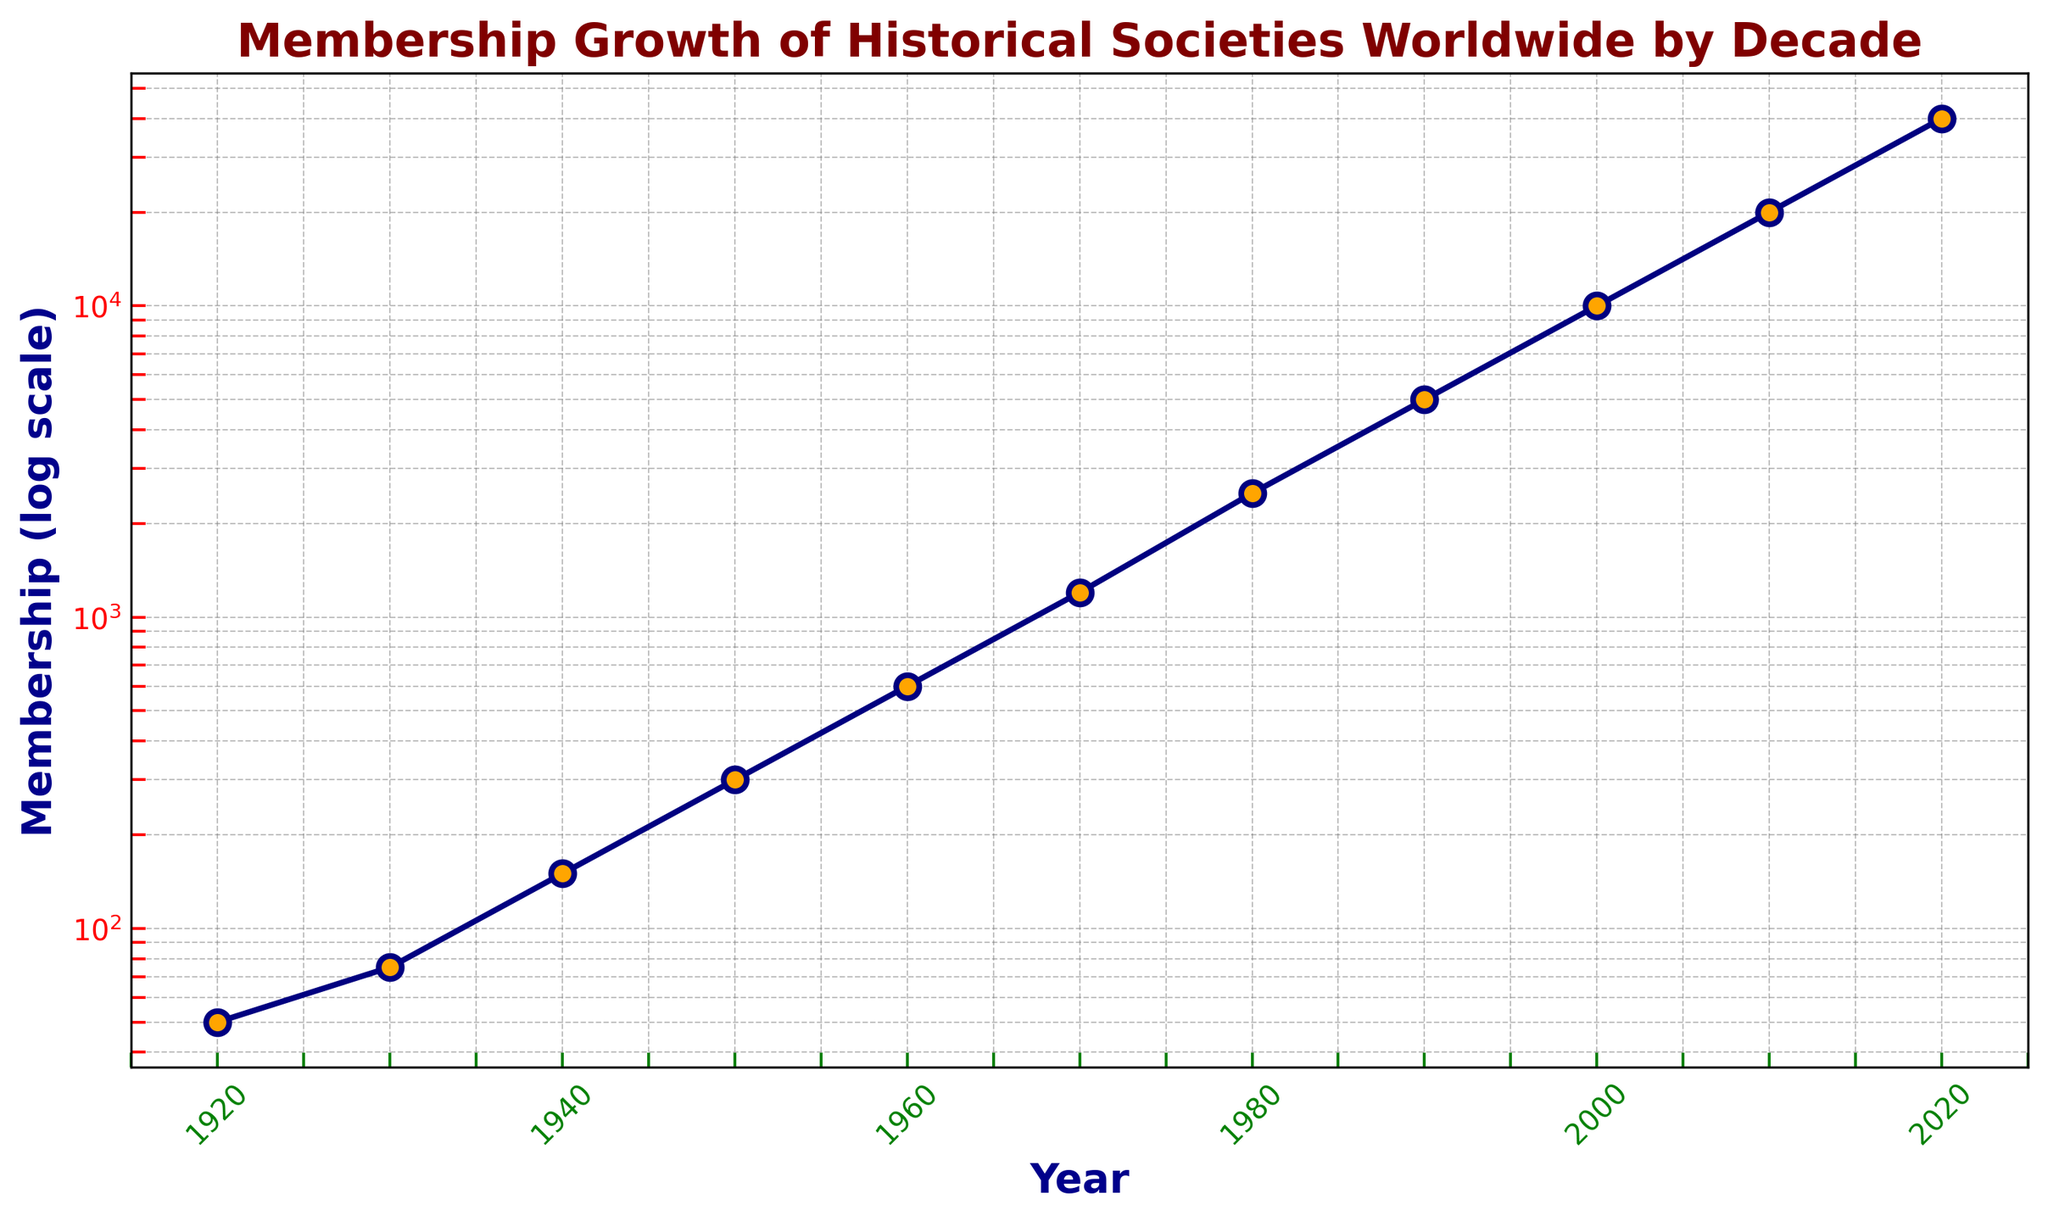When did the membership of historical societies first reach 10000? Looking at the chart, the membership first reaches 10000 around the year 2000.
Answer: 2000 Between which decades did the membership see the greatest increase in terms of the ratio of the two values? To find the greatest increase in terms of ratio, check the gap between consecutive points. The greatest increase ratio occurs between 1990 (5000 members) and 2000 (10000 members), doubling the membership.
Answer: 1990 and 2000 What was the membership count in 1940 compared to 1960? The membership in 1940 was 150 and in 1960 it was 600. By comparing these values, we see that the count in 1960 was four times greater than in 1940.
Answer: Four times greater By how many times did the membership increase from 1970 to 2020? The membership in 1970 was 1200, and in 2020 it reached 40000. The increase is calculated as 40000 / 1200 ≈ 33.3.
Answer: About 33.3 times Which decade saw the first instance of the membership rate reaching at least 10 times the value of the initial 1920 figure? The initial 1920 figure was 50. The decade when the membership first reached at least 500 (10 times 50) is the 1950s with 300. However, it crossed 500 in 1960 with 600 members.
Answer: 1960 